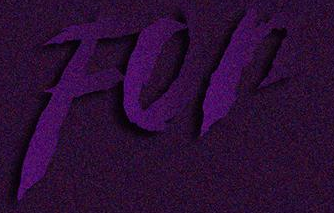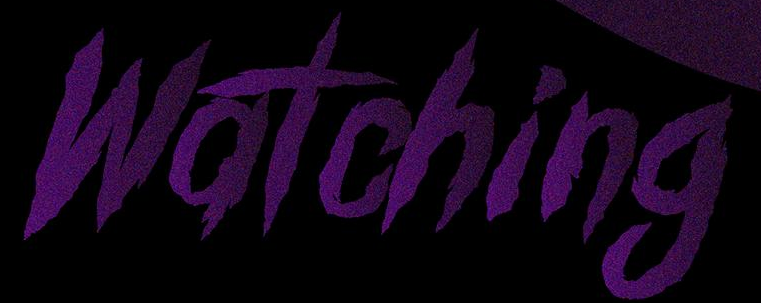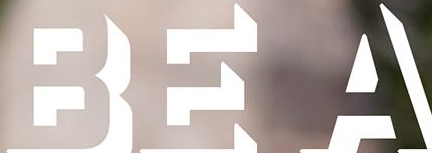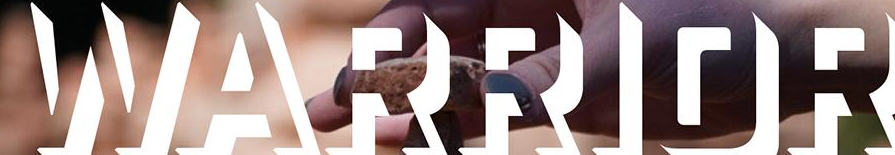What words can you see in these images in sequence, separated by a semicolon? For; Watching; BEA; WARRIOR 